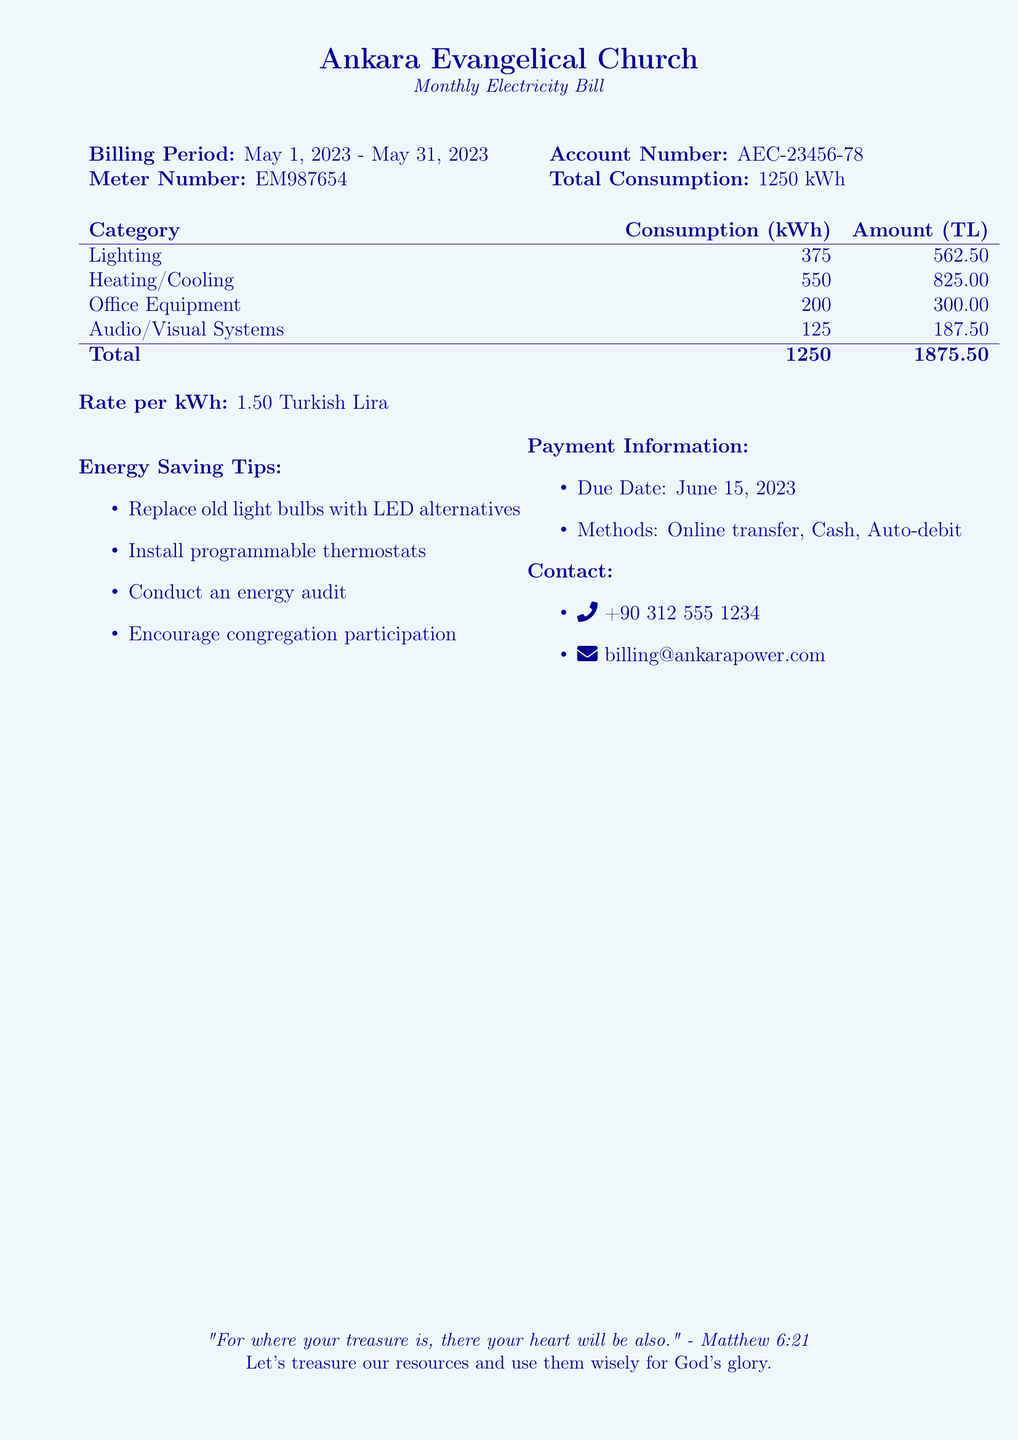What is the billing period? The billing period is found stated directly in the document specifying the start and end dates of the bill.
Answer: May 1, 2023 - May 31, 2023 What is the total consumption of electricity? The total consumption is provided in the table summarizing the energy used during the billing period.
Answer: 1250 kWh What is the total amount due? The total amount due is the sum of all amounts for the categories listed, which appears as a bold total in the document.
Answer: 1875.50 TL How much is charged for lighting? The amount charged for lighting is detailed in the itemized breakdown of the bill.
Answer: 562.50 TL What is the rate per kilowatt-hour? The rate per kilowatt-hour is clearly stated in the document, which helps in calculating costs.
Answer: 1.50 Turkish Lira What is one of the energy saving tips listed? The tips are provided in a bullet list, showcasing simple actions to reduce energy consumption.
Answer: Replace old light bulbs with LED alternatives When is the payment due date? The due date for the payment is mentioned under the payment information.
Answer: June 15, 2023 What payment methods are available? The document specifies various ways to settle the bill, listed for convenience.
Answer: Online transfer, Cash, Auto-debit What is the contact phone number for billing inquiries? The contact information includes a phone number that can be used for questions regarding the bill.
Answer: +90 312 555 1234 